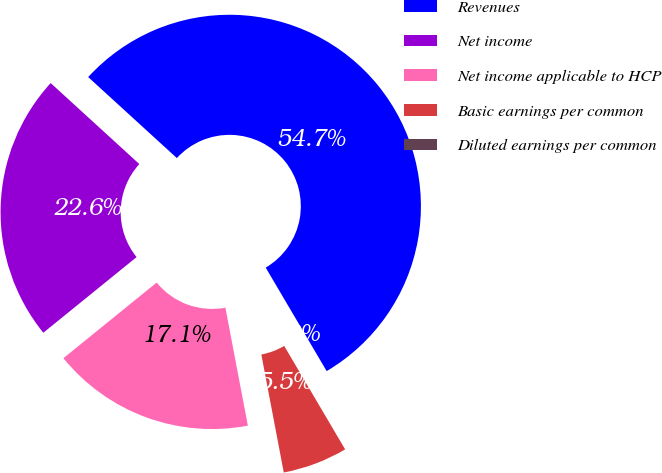<chart> <loc_0><loc_0><loc_500><loc_500><pie_chart><fcel>Revenues<fcel>Net income<fcel>Net income applicable to HCP<fcel>Basic earnings per common<fcel>Diluted earnings per common<nl><fcel>54.75%<fcel>22.63%<fcel>17.15%<fcel>5.48%<fcel>0.0%<nl></chart> 